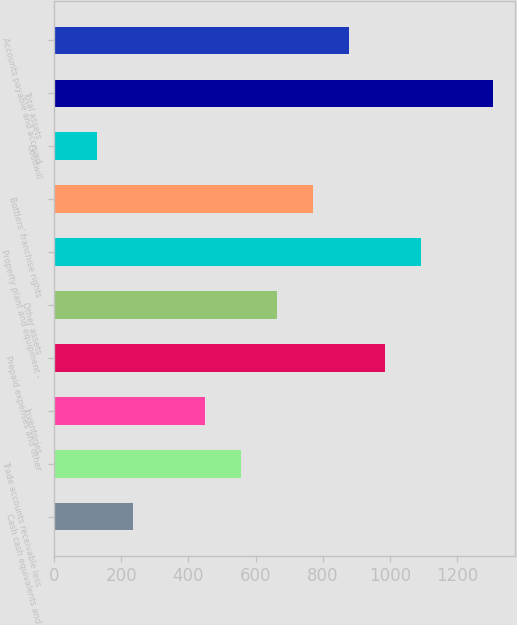Convert chart. <chart><loc_0><loc_0><loc_500><loc_500><bar_chart><fcel>Cash cash equivalents and<fcel>Trade accounts receivable less<fcel>Inventories<fcel>Prepaid expenses and other<fcel>Other assets<fcel>Property plant and equipment -<fcel>Bottlers' franchise rights<fcel>Goodwill<fcel>Total assets<fcel>Accounts payable and accrued<nl><fcel>234.4<fcel>556<fcel>448.8<fcel>984.8<fcel>663.2<fcel>1092<fcel>770.4<fcel>127.2<fcel>1306.4<fcel>877.6<nl></chart> 